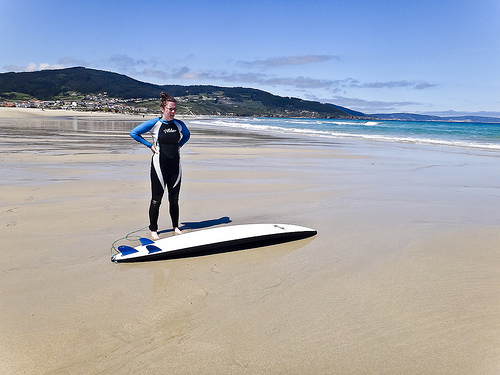Please provide a short description for this region: [0.31, 0.3, 0.36, 0.37]. This detailed region focuses narrowly on a woman's hairstyle which is practical yet stylishly held up to facilitate her aquatic activities without hindrance. 